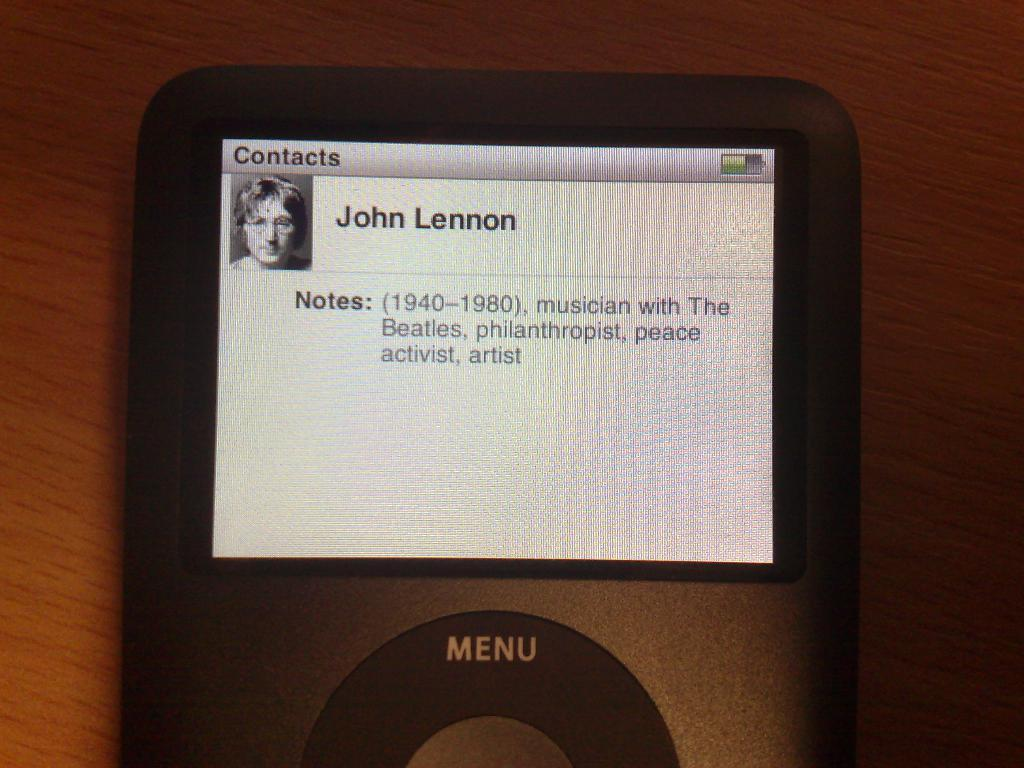What electronic device is visible in the image? There is a mobile phone in the image. What is the mobile phone placed on or near in the image? There is a table below the mobile phone in the image. How many fish are swimming in the pen in the image? There are no fish or pens present in the image; it only features a mobile phone and a table. 